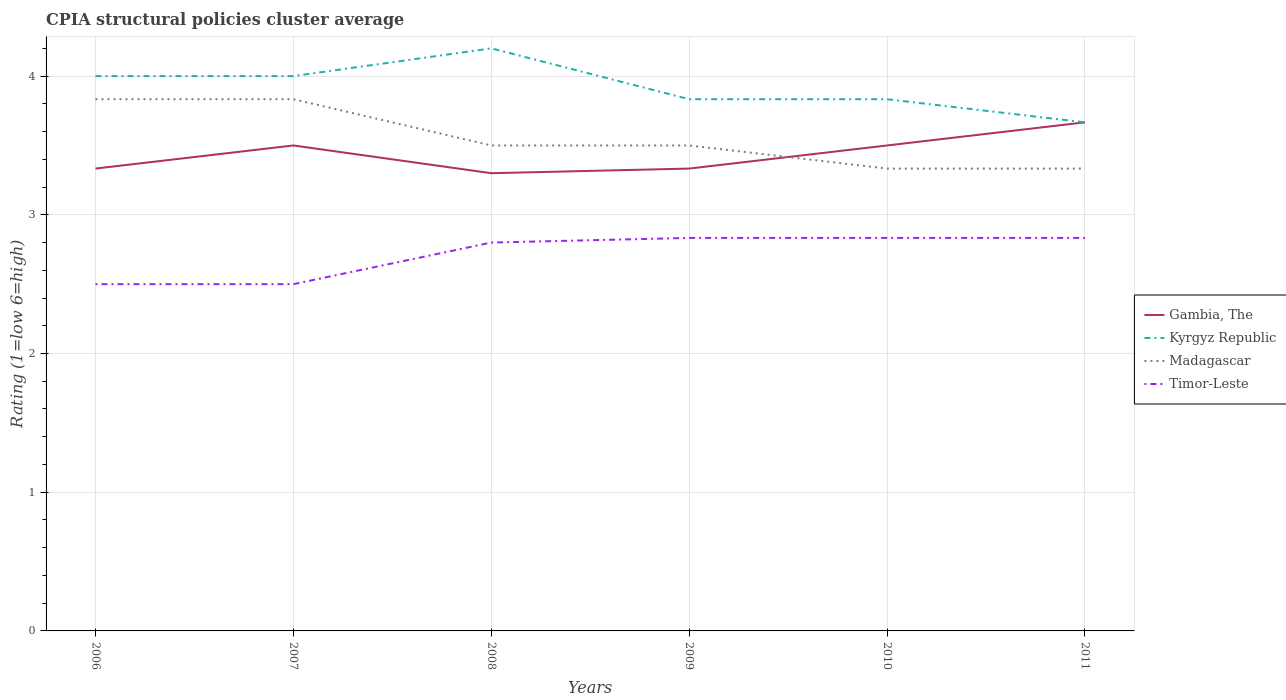How many different coloured lines are there?
Give a very brief answer. 4. Is the number of lines equal to the number of legend labels?
Ensure brevity in your answer.  Yes. Across all years, what is the maximum CPIA rating in Madagascar?
Your response must be concise. 3.33. In which year was the CPIA rating in Madagascar maximum?
Provide a succinct answer. 2010. What is the total CPIA rating in Gambia, The in the graph?
Your answer should be very brief. -0.2. What is the difference between the highest and the second highest CPIA rating in Timor-Leste?
Your response must be concise. 0.33. How many years are there in the graph?
Offer a very short reply. 6. What is the difference between two consecutive major ticks on the Y-axis?
Your response must be concise. 1. Are the values on the major ticks of Y-axis written in scientific E-notation?
Offer a very short reply. No. How many legend labels are there?
Offer a terse response. 4. What is the title of the graph?
Offer a very short reply. CPIA structural policies cluster average. Does "Malta" appear as one of the legend labels in the graph?
Your answer should be very brief. No. What is the label or title of the Y-axis?
Your answer should be very brief. Rating (1=low 6=high). What is the Rating (1=low 6=high) in Gambia, The in 2006?
Keep it short and to the point. 3.33. What is the Rating (1=low 6=high) of Kyrgyz Republic in 2006?
Offer a terse response. 4. What is the Rating (1=low 6=high) of Madagascar in 2006?
Your answer should be compact. 3.83. What is the Rating (1=low 6=high) of Timor-Leste in 2006?
Make the answer very short. 2.5. What is the Rating (1=low 6=high) of Gambia, The in 2007?
Provide a short and direct response. 3.5. What is the Rating (1=low 6=high) in Madagascar in 2007?
Provide a succinct answer. 3.83. What is the Rating (1=low 6=high) of Timor-Leste in 2007?
Make the answer very short. 2.5. What is the Rating (1=low 6=high) in Gambia, The in 2008?
Your response must be concise. 3.3. What is the Rating (1=low 6=high) of Gambia, The in 2009?
Offer a very short reply. 3.33. What is the Rating (1=low 6=high) of Kyrgyz Republic in 2009?
Keep it short and to the point. 3.83. What is the Rating (1=low 6=high) of Timor-Leste in 2009?
Keep it short and to the point. 2.83. What is the Rating (1=low 6=high) of Gambia, The in 2010?
Ensure brevity in your answer.  3.5. What is the Rating (1=low 6=high) in Kyrgyz Republic in 2010?
Your response must be concise. 3.83. What is the Rating (1=low 6=high) of Madagascar in 2010?
Give a very brief answer. 3.33. What is the Rating (1=low 6=high) of Timor-Leste in 2010?
Provide a succinct answer. 2.83. What is the Rating (1=low 6=high) in Gambia, The in 2011?
Make the answer very short. 3.67. What is the Rating (1=low 6=high) in Kyrgyz Republic in 2011?
Ensure brevity in your answer.  3.67. What is the Rating (1=low 6=high) of Madagascar in 2011?
Your answer should be very brief. 3.33. What is the Rating (1=low 6=high) of Timor-Leste in 2011?
Give a very brief answer. 2.83. Across all years, what is the maximum Rating (1=low 6=high) in Gambia, The?
Make the answer very short. 3.67. Across all years, what is the maximum Rating (1=low 6=high) of Madagascar?
Your answer should be compact. 3.83. Across all years, what is the maximum Rating (1=low 6=high) in Timor-Leste?
Give a very brief answer. 2.83. Across all years, what is the minimum Rating (1=low 6=high) in Kyrgyz Republic?
Keep it short and to the point. 3.67. Across all years, what is the minimum Rating (1=low 6=high) of Madagascar?
Keep it short and to the point. 3.33. What is the total Rating (1=low 6=high) of Gambia, The in the graph?
Provide a short and direct response. 20.63. What is the total Rating (1=low 6=high) of Kyrgyz Republic in the graph?
Make the answer very short. 23.53. What is the total Rating (1=low 6=high) in Madagascar in the graph?
Keep it short and to the point. 21.33. What is the difference between the Rating (1=low 6=high) in Kyrgyz Republic in 2006 and that in 2007?
Make the answer very short. 0. What is the difference between the Rating (1=low 6=high) of Madagascar in 2006 and that in 2007?
Offer a very short reply. 0. What is the difference between the Rating (1=low 6=high) in Timor-Leste in 2006 and that in 2007?
Offer a terse response. 0. What is the difference between the Rating (1=low 6=high) of Madagascar in 2006 and that in 2008?
Offer a very short reply. 0.33. What is the difference between the Rating (1=low 6=high) of Timor-Leste in 2006 and that in 2008?
Keep it short and to the point. -0.3. What is the difference between the Rating (1=low 6=high) in Gambia, The in 2006 and that in 2009?
Your answer should be very brief. 0. What is the difference between the Rating (1=low 6=high) of Madagascar in 2006 and that in 2009?
Offer a very short reply. 0.33. What is the difference between the Rating (1=low 6=high) of Kyrgyz Republic in 2006 and that in 2010?
Make the answer very short. 0.17. What is the difference between the Rating (1=low 6=high) in Madagascar in 2007 and that in 2008?
Provide a short and direct response. 0.33. What is the difference between the Rating (1=low 6=high) in Timor-Leste in 2007 and that in 2008?
Your answer should be compact. -0.3. What is the difference between the Rating (1=low 6=high) of Kyrgyz Republic in 2007 and that in 2009?
Offer a terse response. 0.17. What is the difference between the Rating (1=low 6=high) in Madagascar in 2007 and that in 2009?
Provide a short and direct response. 0.33. What is the difference between the Rating (1=low 6=high) of Madagascar in 2007 and that in 2011?
Provide a succinct answer. 0.5. What is the difference between the Rating (1=low 6=high) in Gambia, The in 2008 and that in 2009?
Your answer should be compact. -0.03. What is the difference between the Rating (1=low 6=high) in Kyrgyz Republic in 2008 and that in 2009?
Your answer should be compact. 0.37. What is the difference between the Rating (1=low 6=high) of Madagascar in 2008 and that in 2009?
Provide a succinct answer. 0. What is the difference between the Rating (1=low 6=high) of Timor-Leste in 2008 and that in 2009?
Provide a succinct answer. -0.03. What is the difference between the Rating (1=low 6=high) in Kyrgyz Republic in 2008 and that in 2010?
Keep it short and to the point. 0.37. What is the difference between the Rating (1=low 6=high) of Madagascar in 2008 and that in 2010?
Offer a very short reply. 0.17. What is the difference between the Rating (1=low 6=high) in Timor-Leste in 2008 and that in 2010?
Provide a succinct answer. -0.03. What is the difference between the Rating (1=low 6=high) in Gambia, The in 2008 and that in 2011?
Provide a short and direct response. -0.37. What is the difference between the Rating (1=low 6=high) in Kyrgyz Republic in 2008 and that in 2011?
Give a very brief answer. 0.53. What is the difference between the Rating (1=low 6=high) of Timor-Leste in 2008 and that in 2011?
Provide a short and direct response. -0.03. What is the difference between the Rating (1=low 6=high) in Timor-Leste in 2009 and that in 2010?
Your response must be concise. 0. What is the difference between the Rating (1=low 6=high) in Gambia, The in 2009 and that in 2011?
Your answer should be very brief. -0.33. What is the difference between the Rating (1=low 6=high) in Madagascar in 2009 and that in 2011?
Offer a terse response. 0.17. What is the difference between the Rating (1=low 6=high) in Timor-Leste in 2009 and that in 2011?
Offer a terse response. 0. What is the difference between the Rating (1=low 6=high) of Gambia, The in 2006 and the Rating (1=low 6=high) of Kyrgyz Republic in 2007?
Your answer should be very brief. -0.67. What is the difference between the Rating (1=low 6=high) in Gambia, The in 2006 and the Rating (1=low 6=high) in Timor-Leste in 2007?
Your response must be concise. 0.83. What is the difference between the Rating (1=low 6=high) of Kyrgyz Republic in 2006 and the Rating (1=low 6=high) of Timor-Leste in 2007?
Make the answer very short. 1.5. What is the difference between the Rating (1=low 6=high) of Gambia, The in 2006 and the Rating (1=low 6=high) of Kyrgyz Republic in 2008?
Your answer should be compact. -0.87. What is the difference between the Rating (1=low 6=high) of Gambia, The in 2006 and the Rating (1=low 6=high) of Madagascar in 2008?
Provide a succinct answer. -0.17. What is the difference between the Rating (1=low 6=high) in Gambia, The in 2006 and the Rating (1=low 6=high) in Timor-Leste in 2008?
Offer a very short reply. 0.53. What is the difference between the Rating (1=low 6=high) in Kyrgyz Republic in 2006 and the Rating (1=low 6=high) in Timor-Leste in 2008?
Provide a short and direct response. 1.2. What is the difference between the Rating (1=low 6=high) of Madagascar in 2006 and the Rating (1=low 6=high) of Timor-Leste in 2008?
Provide a short and direct response. 1.03. What is the difference between the Rating (1=low 6=high) in Gambia, The in 2006 and the Rating (1=low 6=high) in Madagascar in 2009?
Your answer should be compact. -0.17. What is the difference between the Rating (1=low 6=high) in Gambia, The in 2006 and the Rating (1=low 6=high) in Timor-Leste in 2009?
Provide a succinct answer. 0.5. What is the difference between the Rating (1=low 6=high) in Kyrgyz Republic in 2006 and the Rating (1=low 6=high) in Madagascar in 2009?
Offer a terse response. 0.5. What is the difference between the Rating (1=low 6=high) in Madagascar in 2006 and the Rating (1=low 6=high) in Timor-Leste in 2009?
Offer a very short reply. 1. What is the difference between the Rating (1=low 6=high) of Gambia, The in 2006 and the Rating (1=low 6=high) of Kyrgyz Republic in 2010?
Keep it short and to the point. -0.5. What is the difference between the Rating (1=low 6=high) of Gambia, The in 2006 and the Rating (1=low 6=high) of Timor-Leste in 2010?
Provide a short and direct response. 0.5. What is the difference between the Rating (1=low 6=high) of Kyrgyz Republic in 2006 and the Rating (1=low 6=high) of Madagascar in 2010?
Give a very brief answer. 0.67. What is the difference between the Rating (1=low 6=high) of Gambia, The in 2006 and the Rating (1=low 6=high) of Madagascar in 2011?
Your answer should be very brief. 0. What is the difference between the Rating (1=low 6=high) in Gambia, The in 2006 and the Rating (1=low 6=high) in Timor-Leste in 2011?
Your answer should be compact. 0.5. What is the difference between the Rating (1=low 6=high) in Kyrgyz Republic in 2006 and the Rating (1=low 6=high) in Madagascar in 2011?
Provide a succinct answer. 0.67. What is the difference between the Rating (1=low 6=high) in Kyrgyz Republic in 2006 and the Rating (1=low 6=high) in Timor-Leste in 2011?
Make the answer very short. 1.17. What is the difference between the Rating (1=low 6=high) in Kyrgyz Republic in 2007 and the Rating (1=low 6=high) in Madagascar in 2008?
Provide a short and direct response. 0.5. What is the difference between the Rating (1=low 6=high) of Kyrgyz Republic in 2007 and the Rating (1=low 6=high) of Timor-Leste in 2008?
Provide a succinct answer. 1.2. What is the difference between the Rating (1=low 6=high) in Madagascar in 2007 and the Rating (1=low 6=high) in Timor-Leste in 2008?
Your answer should be compact. 1.03. What is the difference between the Rating (1=low 6=high) in Gambia, The in 2007 and the Rating (1=low 6=high) in Timor-Leste in 2009?
Your answer should be compact. 0.67. What is the difference between the Rating (1=low 6=high) of Kyrgyz Republic in 2007 and the Rating (1=low 6=high) of Madagascar in 2009?
Your answer should be compact. 0.5. What is the difference between the Rating (1=low 6=high) in Madagascar in 2007 and the Rating (1=low 6=high) in Timor-Leste in 2009?
Offer a terse response. 1. What is the difference between the Rating (1=low 6=high) in Kyrgyz Republic in 2007 and the Rating (1=low 6=high) in Timor-Leste in 2010?
Your answer should be very brief. 1.17. What is the difference between the Rating (1=low 6=high) in Madagascar in 2007 and the Rating (1=low 6=high) in Timor-Leste in 2010?
Provide a short and direct response. 1. What is the difference between the Rating (1=low 6=high) in Gambia, The in 2007 and the Rating (1=low 6=high) in Madagascar in 2011?
Give a very brief answer. 0.17. What is the difference between the Rating (1=low 6=high) in Gambia, The in 2007 and the Rating (1=low 6=high) in Timor-Leste in 2011?
Provide a succinct answer. 0.67. What is the difference between the Rating (1=low 6=high) in Kyrgyz Republic in 2007 and the Rating (1=low 6=high) in Madagascar in 2011?
Offer a terse response. 0.67. What is the difference between the Rating (1=low 6=high) in Kyrgyz Republic in 2007 and the Rating (1=low 6=high) in Timor-Leste in 2011?
Offer a very short reply. 1.17. What is the difference between the Rating (1=low 6=high) in Madagascar in 2007 and the Rating (1=low 6=high) in Timor-Leste in 2011?
Make the answer very short. 1. What is the difference between the Rating (1=low 6=high) in Gambia, The in 2008 and the Rating (1=low 6=high) in Kyrgyz Republic in 2009?
Ensure brevity in your answer.  -0.53. What is the difference between the Rating (1=low 6=high) in Gambia, The in 2008 and the Rating (1=low 6=high) in Timor-Leste in 2009?
Make the answer very short. 0.47. What is the difference between the Rating (1=low 6=high) of Kyrgyz Republic in 2008 and the Rating (1=low 6=high) of Madagascar in 2009?
Your response must be concise. 0.7. What is the difference between the Rating (1=low 6=high) in Kyrgyz Republic in 2008 and the Rating (1=low 6=high) in Timor-Leste in 2009?
Keep it short and to the point. 1.37. What is the difference between the Rating (1=low 6=high) of Gambia, The in 2008 and the Rating (1=low 6=high) of Kyrgyz Republic in 2010?
Offer a terse response. -0.53. What is the difference between the Rating (1=low 6=high) in Gambia, The in 2008 and the Rating (1=low 6=high) in Madagascar in 2010?
Provide a succinct answer. -0.03. What is the difference between the Rating (1=low 6=high) of Gambia, The in 2008 and the Rating (1=low 6=high) of Timor-Leste in 2010?
Provide a short and direct response. 0.47. What is the difference between the Rating (1=low 6=high) of Kyrgyz Republic in 2008 and the Rating (1=low 6=high) of Madagascar in 2010?
Your response must be concise. 0.87. What is the difference between the Rating (1=low 6=high) in Kyrgyz Republic in 2008 and the Rating (1=low 6=high) in Timor-Leste in 2010?
Your answer should be very brief. 1.37. What is the difference between the Rating (1=low 6=high) in Madagascar in 2008 and the Rating (1=low 6=high) in Timor-Leste in 2010?
Your response must be concise. 0.67. What is the difference between the Rating (1=low 6=high) of Gambia, The in 2008 and the Rating (1=low 6=high) of Kyrgyz Republic in 2011?
Your answer should be very brief. -0.37. What is the difference between the Rating (1=low 6=high) in Gambia, The in 2008 and the Rating (1=low 6=high) in Madagascar in 2011?
Provide a short and direct response. -0.03. What is the difference between the Rating (1=low 6=high) in Gambia, The in 2008 and the Rating (1=low 6=high) in Timor-Leste in 2011?
Provide a succinct answer. 0.47. What is the difference between the Rating (1=low 6=high) in Kyrgyz Republic in 2008 and the Rating (1=low 6=high) in Madagascar in 2011?
Keep it short and to the point. 0.87. What is the difference between the Rating (1=low 6=high) of Kyrgyz Republic in 2008 and the Rating (1=low 6=high) of Timor-Leste in 2011?
Your answer should be compact. 1.37. What is the difference between the Rating (1=low 6=high) of Kyrgyz Republic in 2009 and the Rating (1=low 6=high) of Timor-Leste in 2010?
Make the answer very short. 1. What is the difference between the Rating (1=low 6=high) of Gambia, The in 2009 and the Rating (1=low 6=high) of Madagascar in 2011?
Your response must be concise. 0. What is the difference between the Rating (1=low 6=high) of Madagascar in 2009 and the Rating (1=low 6=high) of Timor-Leste in 2011?
Keep it short and to the point. 0.67. What is the difference between the Rating (1=low 6=high) of Gambia, The in 2010 and the Rating (1=low 6=high) of Kyrgyz Republic in 2011?
Keep it short and to the point. -0.17. What is the difference between the Rating (1=low 6=high) in Gambia, The in 2010 and the Rating (1=low 6=high) in Madagascar in 2011?
Your answer should be compact. 0.17. What is the difference between the Rating (1=low 6=high) of Gambia, The in 2010 and the Rating (1=low 6=high) of Timor-Leste in 2011?
Provide a short and direct response. 0.67. What is the average Rating (1=low 6=high) in Gambia, The per year?
Provide a succinct answer. 3.44. What is the average Rating (1=low 6=high) of Kyrgyz Republic per year?
Keep it short and to the point. 3.92. What is the average Rating (1=low 6=high) in Madagascar per year?
Provide a short and direct response. 3.56. What is the average Rating (1=low 6=high) in Timor-Leste per year?
Your answer should be compact. 2.72. In the year 2006, what is the difference between the Rating (1=low 6=high) of Gambia, The and Rating (1=low 6=high) of Timor-Leste?
Offer a terse response. 0.83. In the year 2007, what is the difference between the Rating (1=low 6=high) in Gambia, The and Rating (1=low 6=high) in Madagascar?
Offer a very short reply. -0.33. In the year 2007, what is the difference between the Rating (1=low 6=high) of Gambia, The and Rating (1=low 6=high) of Timor-Leste?
Your response must be concise. 1. In the year 2007, what is the difference between the Rating (1=low 6=high) of Kyrgyz Republic and Rating (1=low 6=high) of Madagascar?
Give a very brief answer. 0.17. In the year 2008, what is the difference between the Rating (1=low 6=high) of Gambia, The and Rating (1=low 6=high) of Timor-Leste?
Make the answer very short. 0.5. In the year 2008, what is the difference between the Rating (1=low 6=high) in Kyrgyz Republic and Rating (1=low 6=high) in Timor-Leste?
Your response must be concise. 1.4. In the year 2009, what is the difference between the Rating (1=low 6=high) in Gambia, The and Rating (1=low 6=high) in Madagascar?
Ensure brevity in your answer.  -0.17. In the year 2009, what is the difference between the Rating (1=low 6=high) of Gambia, The and Rating (1=low 6=high) of Timor-Leste?
Make the answer very short. 0.5. In the year 2009, what is the difference between the Rating (1=low 6=high) of Kyrgyz Republic and Rating (1=low 6=high) of Madagascar?
Give a very brief answer. 0.33. In the year 2010, what is the difference between the Rating (1=low 6=high) in Gambia, The and Rating (1=low 6=high) in Kyrgyz Republic?
Make the answer very short. -0.33. In the year 2010, what is the difference between the Rating (1=low 6=high) in Gambia, The and Rating (1=low 6=high) in Madagascar?
Offer a terse response. 0.17. In the year 2010, what is the difference between the Rating (1=low 6=high) in Kyrgyz Republic and Rating (1=low 6=high) in Madagascar?
Your answer should be compact. 0.5. In the year 2010, what is the difference between the Rating (1=low 6=high) in Kyrgyz Republic and Rating (1=low 6=high) in Timor-Leste?
Ensure brevity in your answer.  1. In the year 2011, what is the difference between the Rating (1=low 6=high) of Gambia, The and Rating (1=low 6=high) of Kyrgyz Republic?
Provide a short and direct response. 0. In the year 2011, what is the difference between the Rating (1=low 6=high) in Gambia, The and Rating (1=low 6=high) in Madagascar?
Your answer should be compact. 0.33. In the year 2011, what is the difference between the Rating (1=low 6=high) of Gambia, The and Rating (1=low 6=high) of Timor-Leste?
Provide a succinct answer. 0.83. In the year 2011, what is the difference between the Rating (1=low 6=high) of Kyrgyz Republic and Rating (1=low 6=high) of Madagascar?
Offer a terse response. 0.33. In the year 2011, what is the difference between the Rating (1=low 6=high) in Kyrgyz Republic and Rating (1=low 6=high) in Timor-Leste?
Make the answer very short. 0.83. In the year 2011, what is the difference between the Rating (1=low 6=high) of Madagascar and Rating (1=low 6=high) of Timor-Leste?
Ensure brevity in your answer.  0.5. What is the ratio of the Rating (1=low 6=high) of Gambia, The in 2006 to that in 2007?
Your answer should be compact. 0.95. What is the ratio of the Rating (1=low 6=high) of Madagascar in 2006 to that in 2007?
Offer a very short reply. 1. What is the ratio of the Rating (1=low 6=high) in Timor-Leste in 2006 to that in 2007?
Give a very brief answer. 1. What is the ratio of the Rating (1=low 6=high) of Gambia, The in 2006 to that in 2008?
Make the answer very short. 1.01. What is the ratio of the Rating (1=low 6=high) in Kyrgyz Republic in 2006 to that in 2008?
Provide a short and direct response. 0.95. What is the ratio of the Rating (1=low 6=high) of Madagascar in 2006 to that in 2008?
Your response must be concise. 1.1. What is the ratio of the Rating (1=low 6=high) in Timor-Leste in 2006 to that in 2008?
Keep it short and to the point. 0.89. What is the ratio of the Rating (1=low 6=high) in Gambia, The in 2006 to that in 2009?
Ensure brevity in your answer.  1. What is the ratio of the Rating (1=low 6=high) in Kyrgyz Republic in 2006 to that in 2009?
Keep it short and to the point. 1.04. What is the ratio of the Rating (1=low 6=high) of Madagascar in 2006 to that in 2009?
Offer a terse response. 1.1. What is the ratio of the Rating (1=low 6=high) in Timor-Leste in 2006 to that in 2009?
Ensure brevity in your answer.  0.88. What is the ratio of the Rating (1=low 6=high) in Gambia, The in 2006 to that in 2010?
Make the answer very short. 0.95. What is the ratio of the Rating (1=low 6=high) of Kyrgyz Republic in 2006 to that in 2010?
Your answer should be compact. 1.04. What is the ratio of the Rating (1=low 6=high) of Madagascar in 2006 to that in 2010?
Provide a succinct answer. 1.15. What is the ratio of the Rating (1=low 6=high) in Timor-Leste in 2006 to that in 2010?
Keep it short and to the point. 0.88. What is the ratio of the Rating (1=low 6=high) in Kyrgyz Republic in 2006 to that in 2011?
Your response must be concise. 1.09. What is the ratio of the Rating (1=low 6=high) in Madagascar in 2006 to that in 2011?
Offer a terse response. 1.15. What is the ratio of the Rating (1=low 6=high) in Timor-Leste in 2006 to that in 2011?
Provide a short and direct response. 0.88. What is the ratio of the Rating (1=low 6=high) in Gambia, The in 2007 to that in 2008?
Offer a very short reply. 1.06. What is the ratio of the Rating (1=low 6=high) of Madagascar in 2007 to that in 2008?
Keep it short and to the point. 1.1. What is the ratio of the Rating (1=low 6=high) of Timor-Leste in 2007 to that in 2008?
Ensure brevity in your answer.  0.89. What is the ratio of the Rating (1=low 6=high) in Kyrgyz Republic in 2007 to that in 2009?
Offer a very short reply. 1.04. What is the ratio of the Rating (1=low 6=high) in Madagascar in 2007 to that in 2009?
Keep it short and to the point. 1.1. What is the ratio of the Rating (1=low 6=high) of Timor-Leste in 2007 to that in 2009?
Your answer should be compact. 0.88. What is the ratio of the Rating (1=low 6=high) of Gambia, The in 2007 to that in 2010?
Keep it short and to the point. 1. What is the ratio of the Rating (1=low 6=high) of Kyrgyz Republic in 2007 to that in 2010?
Your response must be concise. 1.04. What is the ratio of the Rating (1=low 6=high) of Madagascar in 2007 to that in 2010?
Keep it short and to the point. 1.15. What is the ratio of the Rating (1=low 6=high) of Timor-Leste in 2007 to that in 2010?
Your answer should be very brief. 0.88. What is the ratio of the Rating (1=low 6=high) of Gambia, The in 2007 to that in 2011?
Your response must be concise. 0.95. What is the ratio of the Rating (1=low 6=high) of Kyrgyz Republic in 2007 to that in 2011?
Make the answer very short. 1.09. What is the ratio of the Rating (1=low 6=high) in Madagascar in 2007 to that in 2011?
Ensure brevity in your answer.  1.15. What is the ratio of the Rating (1=low 6=high) in Timor-Leste in 2007 to that in 2011?
Offer a very short reply. 0.88. What is the ratio of the Rating (1=low 6=high) of Gambia, The in 2008 to that in 2009?
Your answer should be compact. 0.99. What is the ratio of the Rating (1=low 6=high) in Kyrgyz Republic in 2008 to that in 2009?
Give a very brief answer. 1.1. What is the ratio of the Rating (1=low 6=high) of Madagascar in 2008 to that in 2009?
Make the answer very short. 1. What is the ratio of the Rating (1=low 6=high) in Timor-Leste in 2008 to that in 2009?
Give a very brief answer. 0.99. What is the ratio of the Rating (1=low 6=high) in Gambia, The in 2008 to that in 2010?
Offer a very short reply. 0.94. What is the ratio of the Rating (1=low 6=high) of Kyrgyz Republic in 2008 to that in 2010?
Offer a terse response. 1.1. What is the ratio of the Rating (1=low 6=high) in Madagascar in 2008 to that in 2010?
Make the answer very short. 1.05. What is the ratio of the Rating (1=low 6=high) in Timor-Leste in 2008 to that in 2010?
Provide a succinct answer. 0.99. What is the ratio of the Rating (1=low 6=high) in Kyrgyz Republic in 2008 to that in 2011?
Keep it short and to the point. 1.15. What is the ratio of the Rating (1=low 6=high) in Timor-Leste in 2008 to that in 2011?
Offer a terse response. 0.99. What is the ratio of the Rating (1=low 6=high) in Kyrgyz Republic in 2009 to that in 2010?
Your answer should be very brief. 1. What is the ratio of the Rating (1=low 6=high) of Kyrgyz Republic in 2009 to that in 2011?
Keep it short and to the point. 1.05. What is the ratio of the Rating (1=low 6=high) of Madagascar in 2009 to that in 2011?
Give a very brief answer. 1.05. What is the ratio of the Rating (1=low 6=high) in Timor-Leste in 2009 to that in 2011?
Your response must be concise. 1. What is the ratio of the Rating (1=low 6=high) in Gambia, The in 2010 to that in 2011?
Keep it short and to the point. 0.95. What is the ratio of the Rating (1=low 6=high) of Kyrgyz Republic in 2010 to that in 2011?
Make the answer very short. 1.05. What is the ratio of the Rating (1=low 6=high) in Timor-Leste in 2010 to that in 2011?
Ensure brevity in your answer.  1. What is the difference between the highest and the second highest Rating (1=low 6=high) in Gambia, The?
Offer a very short reply. 0.17. What is the difference between the highest and the second highest Rating (1=low 6=high) in Kyrgyz Republic?
Ensure brevity in your answer.  0.2. What is the difference between the highest and the second highest Rating (1=low 6=high) of Madagascar?
Your answer should be compact. 0. What is the difference between the highest and the lowest Rating (1=low 6=high) of Gambia, The?
Ensure brevity in your answer.  0.37. What is the difference between the highest and the lowest Rating (1=low 6=high) in Kyrgyz Republic?
Offer a terse response. 0.53. What is the difference between the highest and the lowest Rating (1=low 6=high) in Madagascar?
Ensure brevity in your answer.  0.5. 